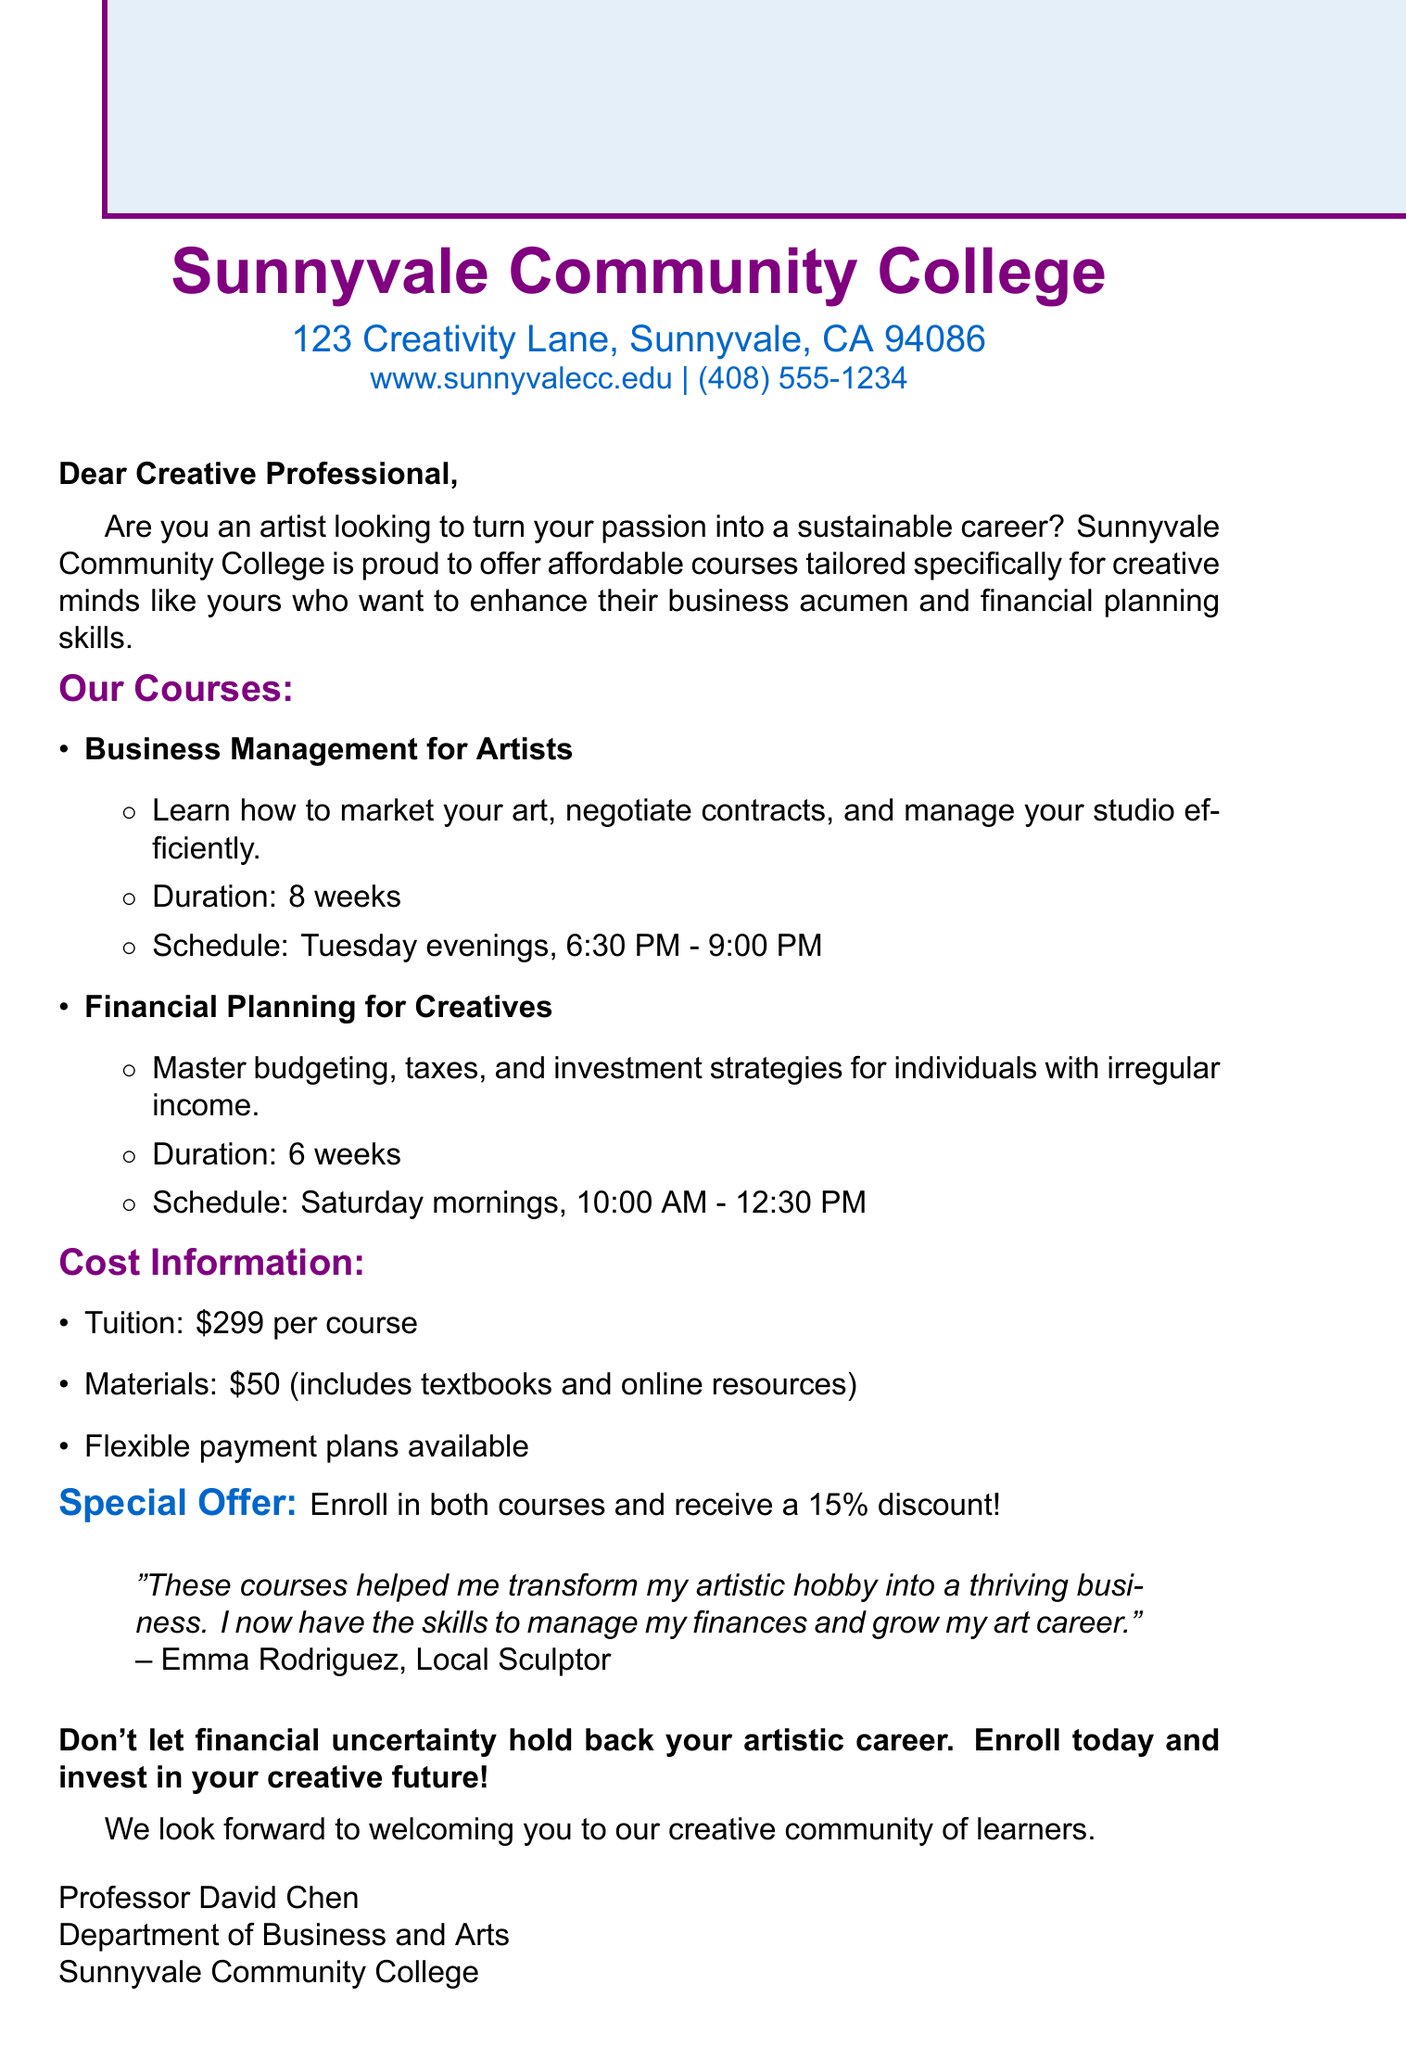What is the name of the college? The name of the college is stated in the document as Sunnyvale Community College.
Answer: Sunnyvale Community College What is the location of the college? The document specifies the exact address of the college as 123 Creativity Lane, Sunnyvale, CA 94086.
Answer: 123 Creativity Lane, Sunnyvale, CA 94086 What is the tuition fee for each course? The document lists the tuition fee for each course as $299.
Answer: $299 How long is the "Business Management for Artists" course? The duration of the "Business Management for Artists" course is mentioned as 8 weeks.
Answer: 8 weeks Which day and time is the "Financial Planning for Creatives" course scheduled? The document indicates that the course is scheduled for Saturday mornings from 10:00 AM to 12:30 PM.
Answer: Saturday mornings, 10:00 AM - 12:30 PM What discount is offered for enrolling in both courses? The document states that a 15% discount is available for enrolling in both courses.
Answer: 15% Who is the author of the testimonial included in the document? The testimonial's author is mentioned in the document as Emma Rodriguez.
Answer: Emma Rodriguez What is the closing statement from the professor? The closing statement encourages enrolling and expresses a welcoming sentiment to the creative community.
Answer: We look forward to welcoming you to our creative community of learners What department does Professor David Chen belong to? The document specifies that Professor David Chen is part of the Department of Business and Arts.
Answer: Department of Business and Arts 